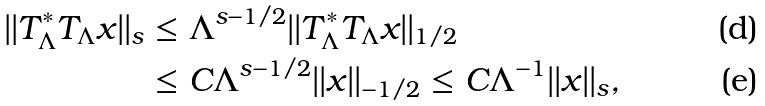Convert formula to latex. <formula><loc_0><loc_0><loc_500><loc_500>| | T _ { \Lambda } ^ { * } T _ { \Lambda } x | | _ { s } & \leq \Lambda ^ { s - 1 / 2 } | | T _ { \Lambda } ^ { * } T _ { \Lambda } x | | _ { 1 / 2 } \\ & \leq C \Lambda ^ { s - 1 / 2 } | | x | | _ { - 1 / 2 } \leq C \Lambda ^ { - 1 } | | x | | _ { s } ,</formula> 